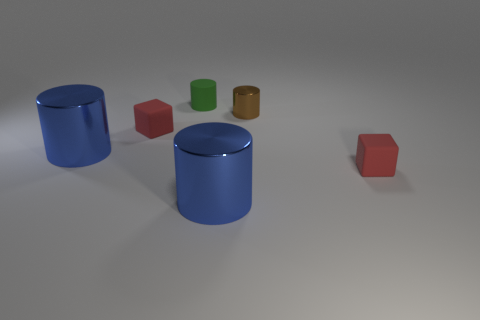What size is the matte cube that is behind the tiny matte block that is in front of the red block that is on the left side of the brown shiny cylinder?
Keep it short and to the point. Small. The small rubber cylinder is what color?
Provide a short and direct response. Green. Are there more red blocks right of the small green matte object than tiny red metallic cubes?
Your response must be concise. Yes. What number of large blue cylinders are left of the small green rubber cylinder?
Ensure brevity in your answer.  1. Are there any large cylinders that are behind the blue cylinder right of the red cube that is on the left side of the tiny matte cylinder?
Ensure brevity in your answer.  Yes. Are there an equal number of small metallic things that are on the right side of the tiny brown metallic thing and small red objects that are left of the tiny green cylinder?
Make the answer very short. No. There is a tiny red matte object to the right of the tiny brown metallic cylinder; what shape is it?
Keep it short and to the point. Cube. What shape is the green matte thing that is the same size as the brown thing?
Offer a terse response. Cylinder. What color is the tiny cylinder that is behind the brown object to the right of the large blue object that is to the left of the green rubber cylinder?
Ensure brevity in your answer.  Green. Are there an equal number of big blue metal cylinders behind the tiny brown cylinder and small green rubber cylinders?
Keep it short and to the point. No. 